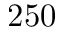Convert formula to latex. <formula><loc_0><loc_0><loc_500><loc_500>2 5 0</formula> 